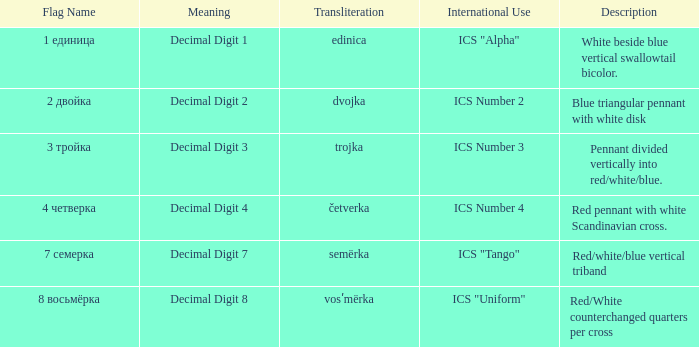What are the meanings of the flag whose name transliterates to semërka? Decimal Digit 7. 